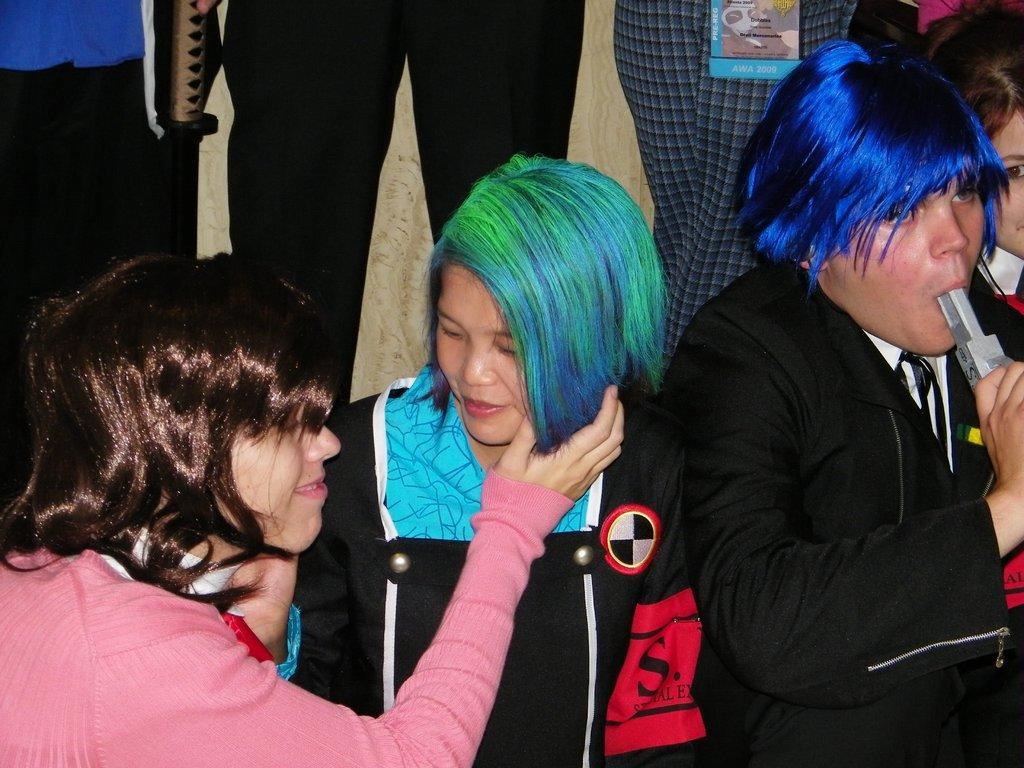Please provide a concise description of this image. In the background we can see the people legs. In this picture we can see people wearing colorful hair wigs. Both women are smiling. On the right side of the picture we can see a man holding an object and he inserted an object in his mouth. 